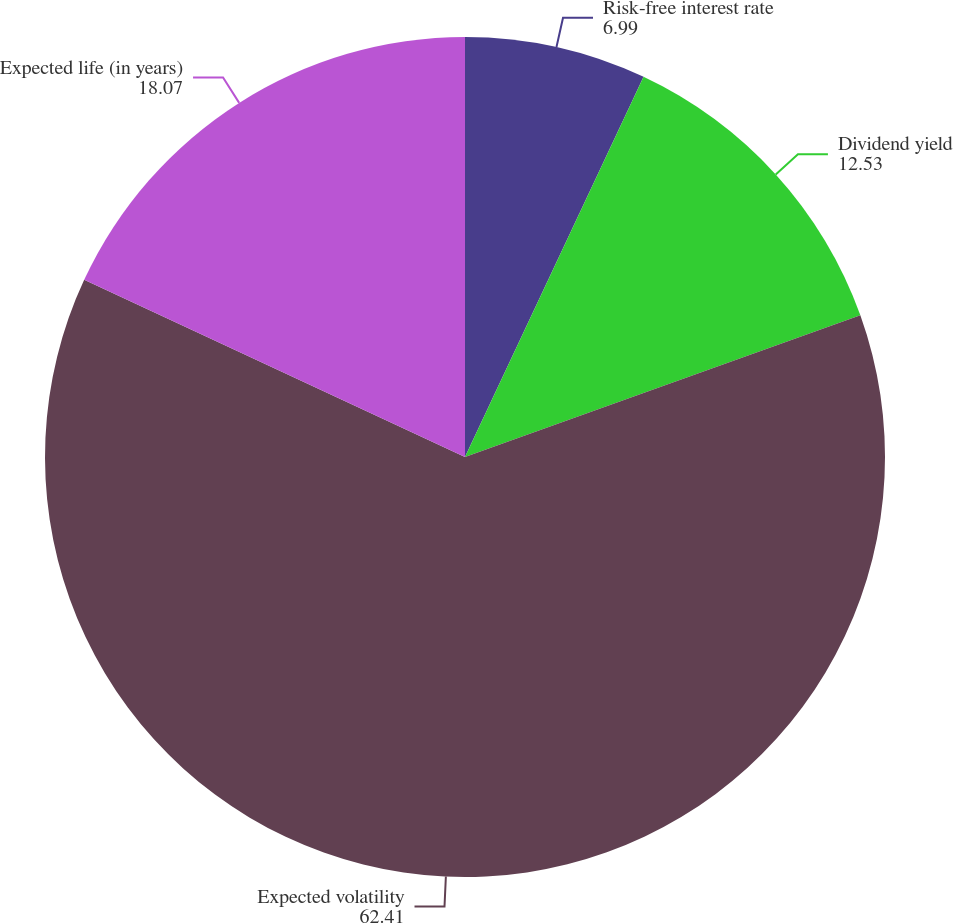Convert chart to OTSL. <chart><loc_0><loc_0><loc_500><loc_500><pie_chart><fcel>Risk-free interest rate<fcel>Dividend yield<fcel>Expected volatility<fcel>Expected life (in years)<nl><fcel>6.99%<fcel>12.53%<fcel>62.41%<fcel>18.07%<nl></chart> 